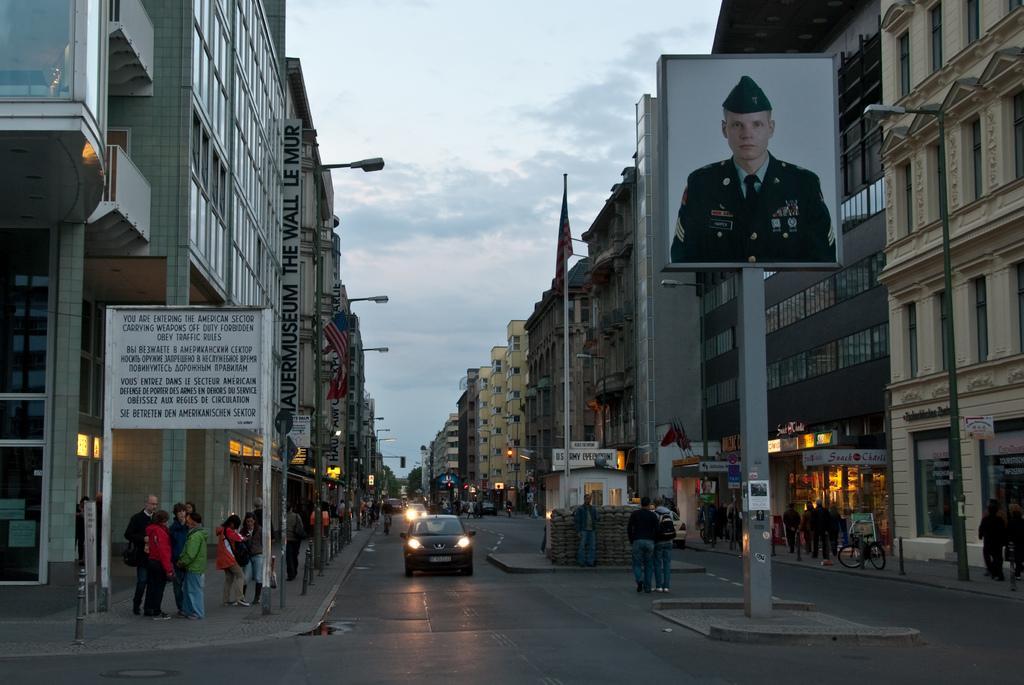Could you give a brief overview of what you see in this image? In this image I can see a road in the centre and on it I can see few vehicles. I can also see number of poles, number of people, number of buildings, two flags, number of lights and on the right side I can see a bicycle. In the background I can see clouds and the sky. On the both sides of the road I can see number of boards and on it I can see something is written. On the right side of the image I can see a board and on it I can see a man's picture. 